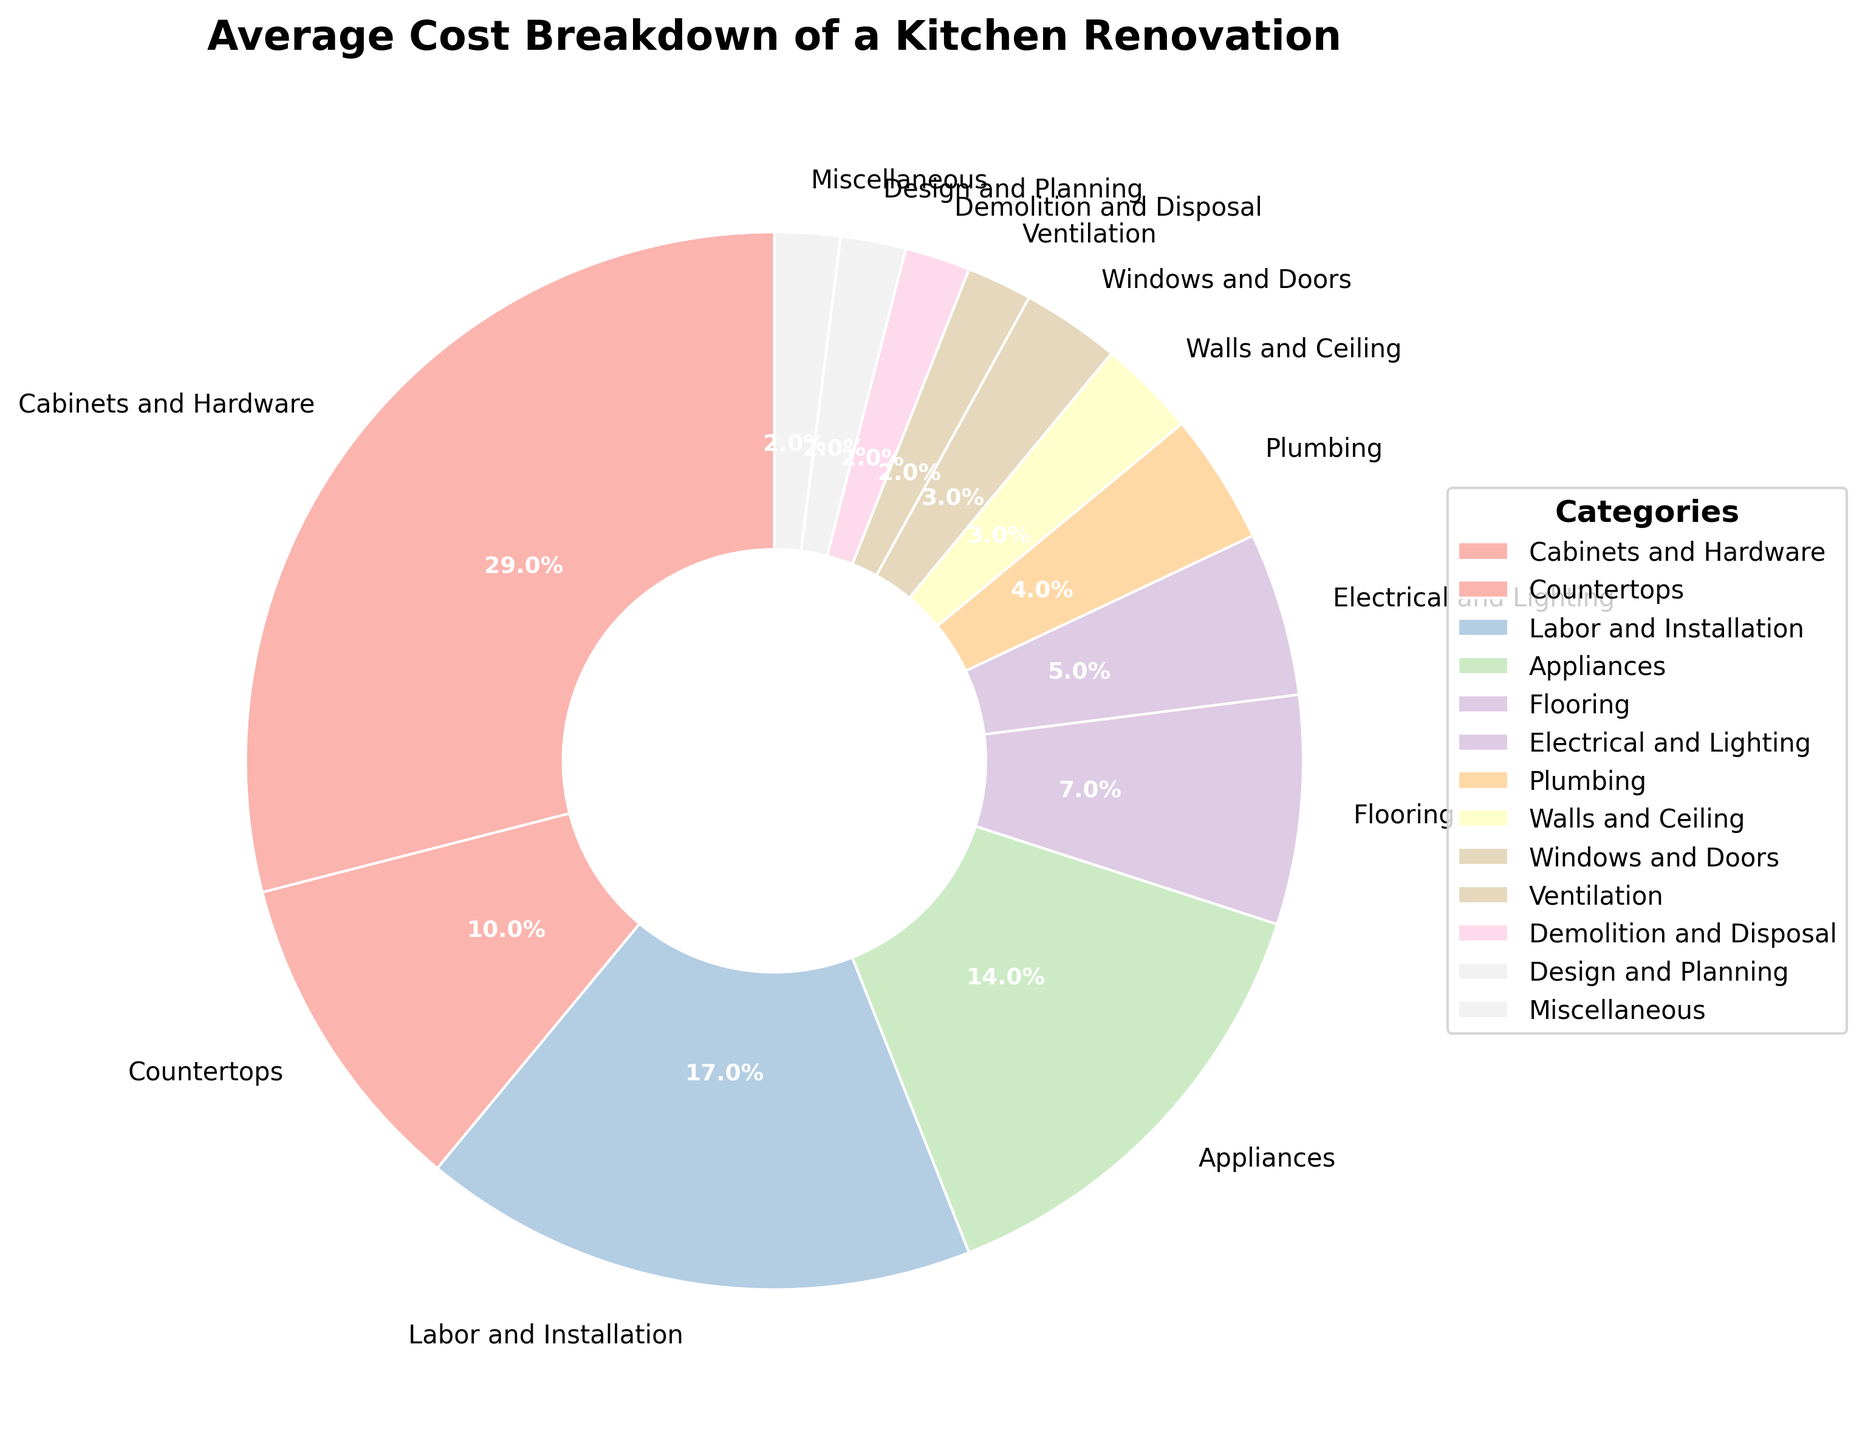What is the largest cost category in a kitchen renovation? The largest section of the pie chart visually represents the category with the highest percentage. Here, the "Cabinets and Hardware" section is the most significant.
Answer: Cabinets and Hardware Which category has a higher cost percentage, Appliances or Electrical and Lighting? By comparing the sizes of the pie sections and their labels, the "Appliances" category (14%) is larger than the "Electrical and Lighting" category (5%).
Answer: Appliances What is the combined cost percentage of Countertops, Flooring, and Electrical and Lighting? To find the combined percentage, add the percentages of each category: Countertops (10%), Flooring (7%), and Electrical and Lighting (5%). So, 10% + 7% + 5% = 22%.
Answer: 22% Are Labor and Installation costs greater than twice the costs of Ventilation? First, find twice the cost of Ventilation: 2 * 2% = 4%. Labor and Installation costs are 17%, which is greater than 4%.
Answer: Yes How much more is spent on Appliances compared to Windows and Doors? Substract the percentage of Windows and Doors from Appliances: 14% - 3% = 11%.
Answer: 11% What cost category is represented by the smallest section of the pie chart and what is its percentage? The smallest section visually corresponds to the smallest percentage. Here, it's "Ventilation," "Demolition and Disposal," "Design and Planning," and "Miscellaneous," each at 2%.
Answer: Ventilation, Demolition and Disposal, Design and Planning, Miscellaneous How does the cost of Demolition and Disposal compare with that of Plumbing? By comparing the sections, the "Demolition and Disposal" (2%) is smaller than "Plumbing" (4%).
Answer: Less What is the total percentage of categories that individually have 5% or less of the cost? Sum up the percentages of Electrical and Lighting (5%), Plumbing (4%), Walls and Ceiling (3%), Windows and Doors (3%), Ventilation (2%), Demolition and Disposal (2%), Design and Planning (2%), and Miscellaneous (2%): 5% + 4% + 3% + 3% + 2% + 2% + 2% + 2% = 23%.
Answer: 23% Which has a higher cost, Flooring or Labor and Installation? Comparing the pie sections, "Labor and Installation" (17%) is higher than "Flooring" (7%).
Answer: Labor and Installation Is the cost of Appliances closer to the cost of Countertops or to the cost of Labor and Installation? Appliances are at 14%, Countertops at 10%, and Labor and Installation at 17%. The difference between Appliances and Countertops is 14% - 10% = 4%, and the difference between Appliances and Labor and Installation is 17% - 14% = 3%.
Answer: Labor and Installation 